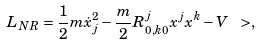<formula> <loc_0><loc_0><loc_500><loc_500>L _ { N R } = \frac { 1 } { 2 } m \dot { x } _ { j } ^ { 2 } - \frac { m } { 2 } R ^ { j } _ { 0 , k 0 } x ^ { j } x ^ { k } - V \ > ,</formula> 